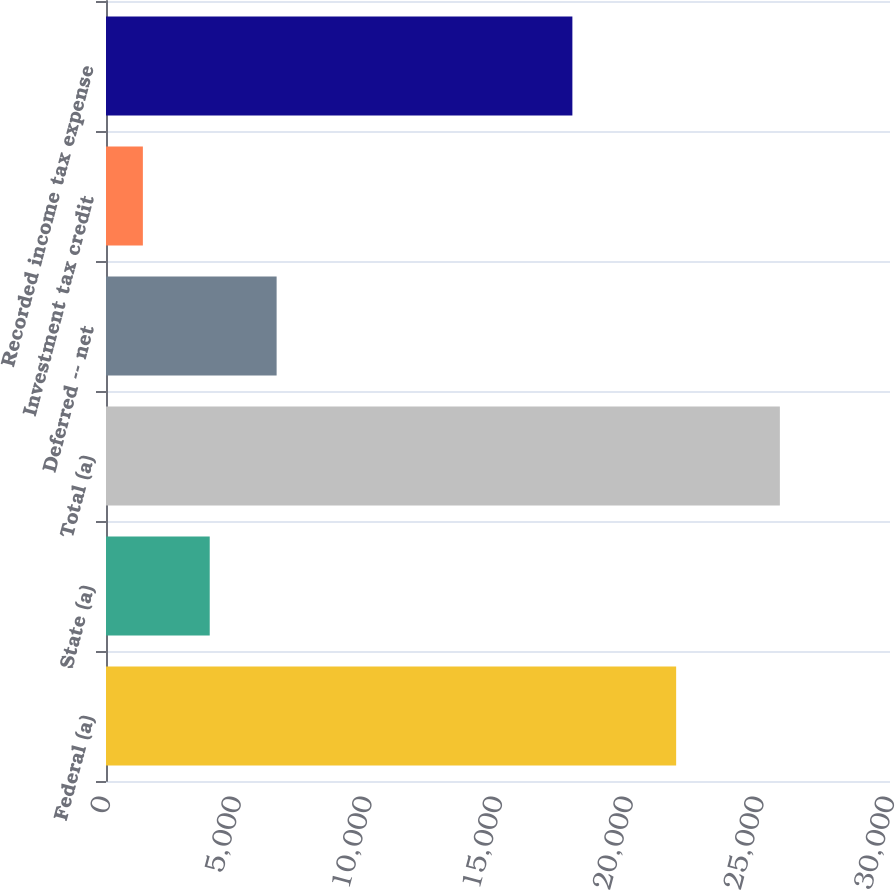Convert chart. <chart><loc_0><loc_0><loc_500><loc_500><bar_chart><fcel>Federal (a)<fcel>State (a)<fcel>Total (a)<fcel>Deferred -- net<fcel>Investment tax credit<fcel>Recorded income tax expense<nl><fcel>21817<fcel>3969<fcel>25786<fcel>6529<fcel>1411<fcel>17846<nl></chart> 